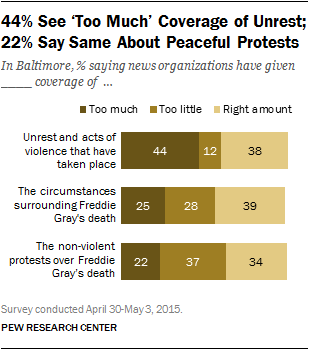Point out several critical features in this image. The difference between the maximum value of 'too much' and the minimum value of 'too little' is 32. The color represented by dark brown is too much. 